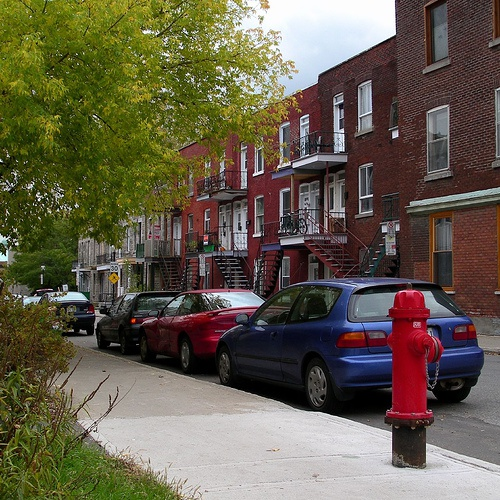Describe the objects in this image and their specific colors. I can see car in olive, black, navy, gray, and maroon tones, fire hydrant in olive, brown, black, maroon, and gray tones, car in olive, black, maroon, gray, and lightgray tones, car in olive, black, gray, darkgray, and purple tones, and car in olive, black, gray, lightblue, and darkgray tones in this image. 